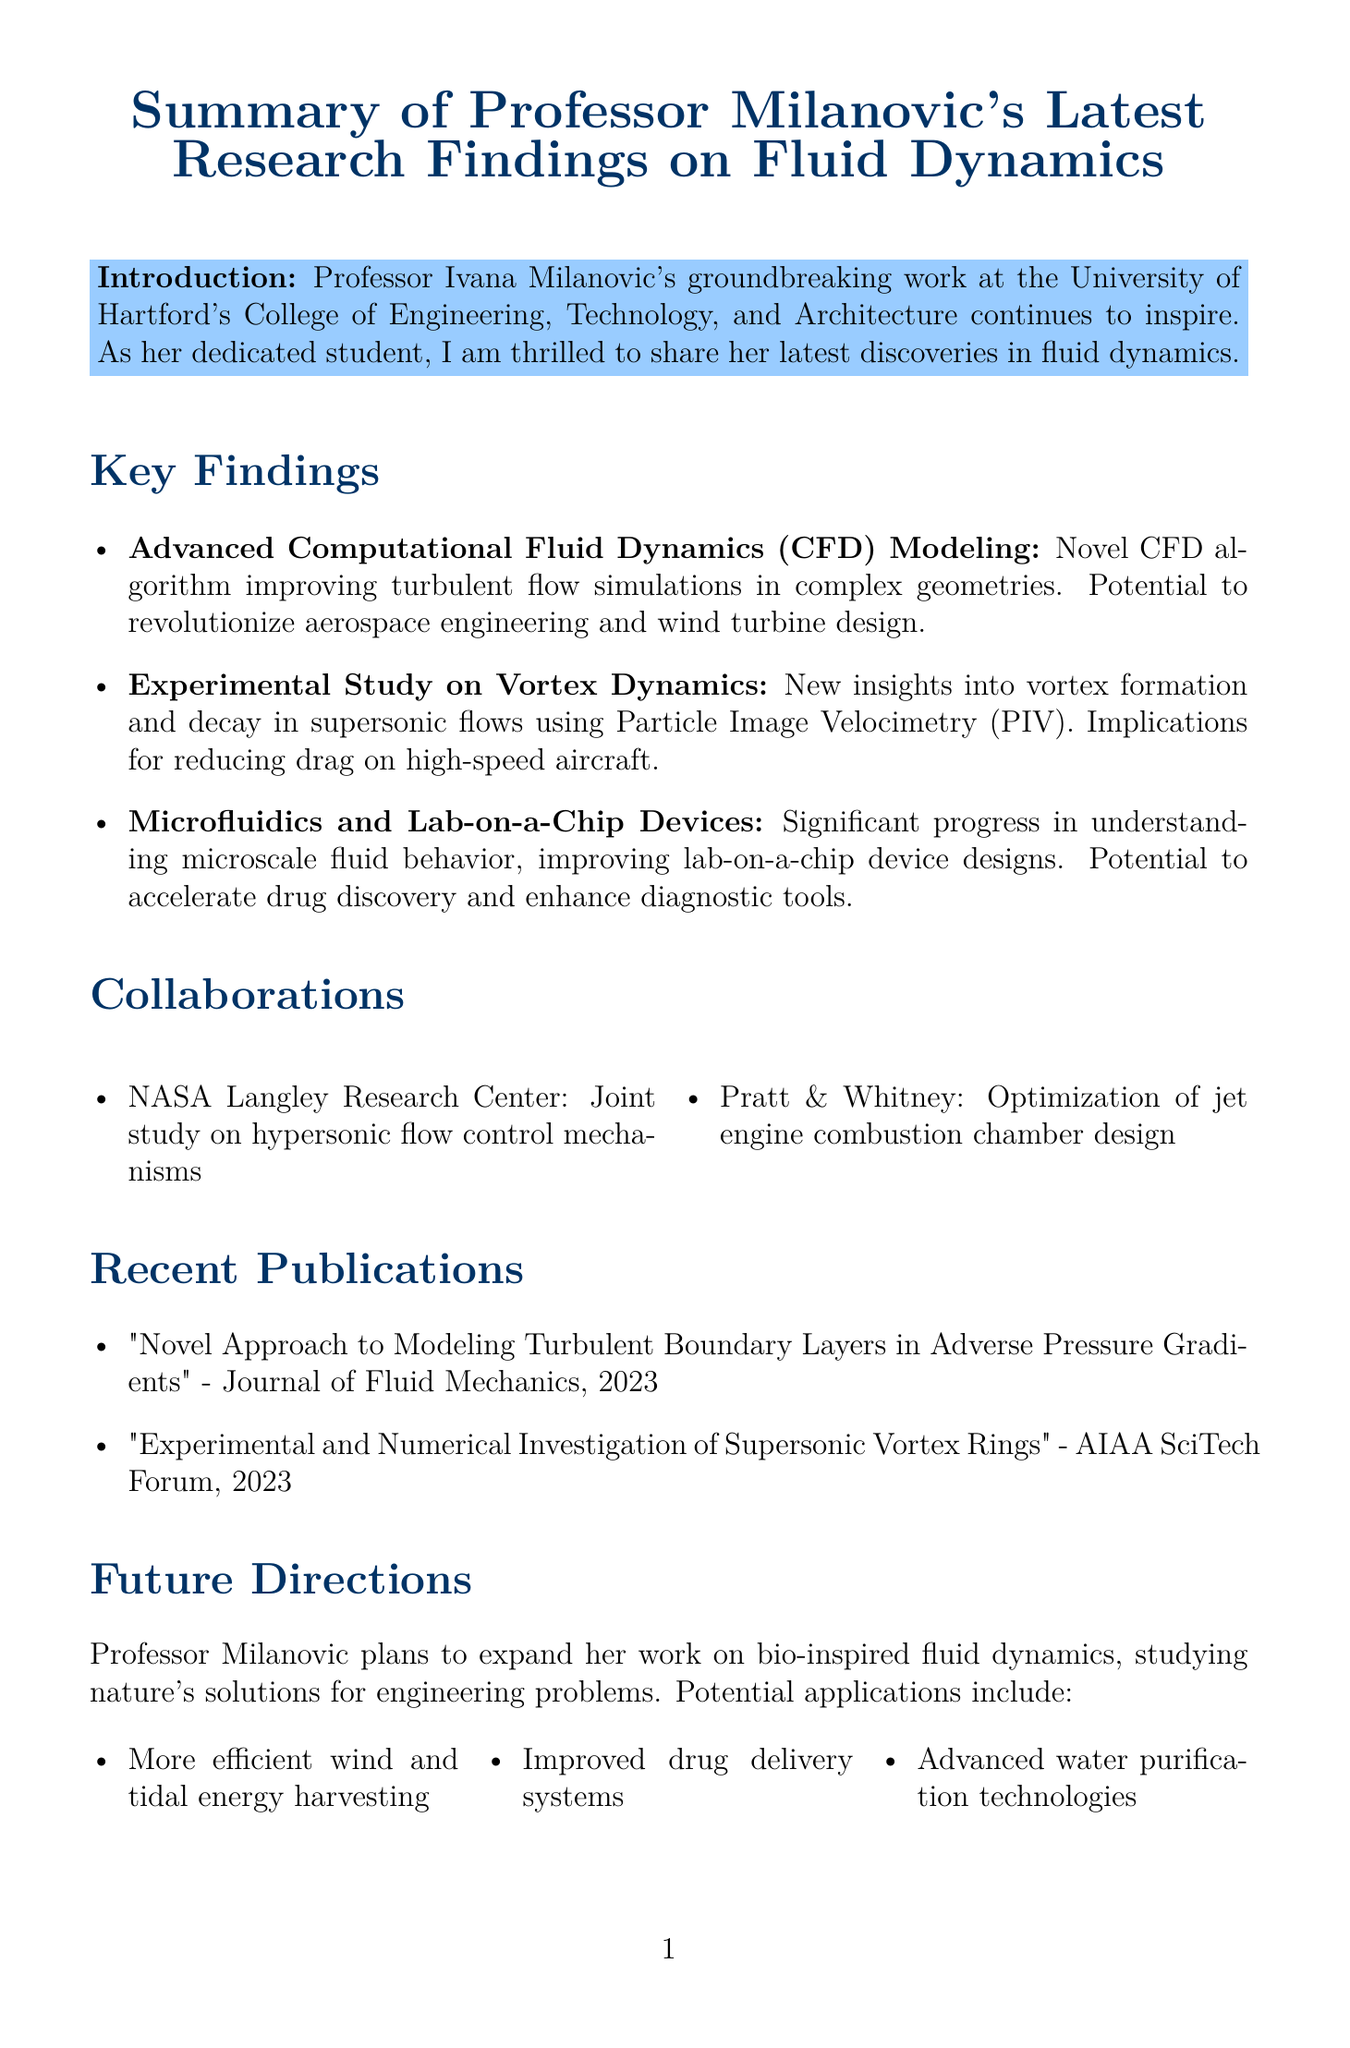What is the title of the memo? The title is presented at the beginning of the document, summarizing the subject of Professor Milanovic's research findings.
Answer: Summary of Professor Milanovic's Latest Research Findings on Fluid Dynamics What organization is Professor Milanovic affiliated with? The document mentions Professor Milanovic's association with the University of Hartford's College of Engineering, Technology, and Architecture.
Answer: University of Hartford What innovative technique did Professor Milanovic use in her experimental study? The memo describes the use of Particle Image Velocimetry (PIV) as a technique in her research on vortex dynamics.
Answer: Particle Image Velocimetry (PIV) In what year did the publication titled "Novel Approach to Modeling Turbulent Boundary Layers in Adverse Pressure Gradients" come out? The year of publication for the mentioned article is displayed alongside its title in the recent publications section.
Answer: 2023 What is one potential application of Professor Milanovic's research in microfluidics? The memo states that her work could enhance drug discovery processes, indicating a practical use for her findings in that field.
Answer: Accelerate drug discovery processes Which institution collaborated with Professor Milanovic on a project related to hypersonic flow? The collaborations section lists NASA Langley Research Center as one of her partners for this particular study.
Answer: NASA Langley Research Center What is the primary future research focus for Professor Milanovic? The future directions section outlines her intention to explore bio-inspired fluid dynamics as a key area of research moving forward.
Answer: Bio-inspired fluid dynamics How many key findings are outlined in the document? By counting the listed key findings, one can determine the total number presented in the memo.
Answer: Three 